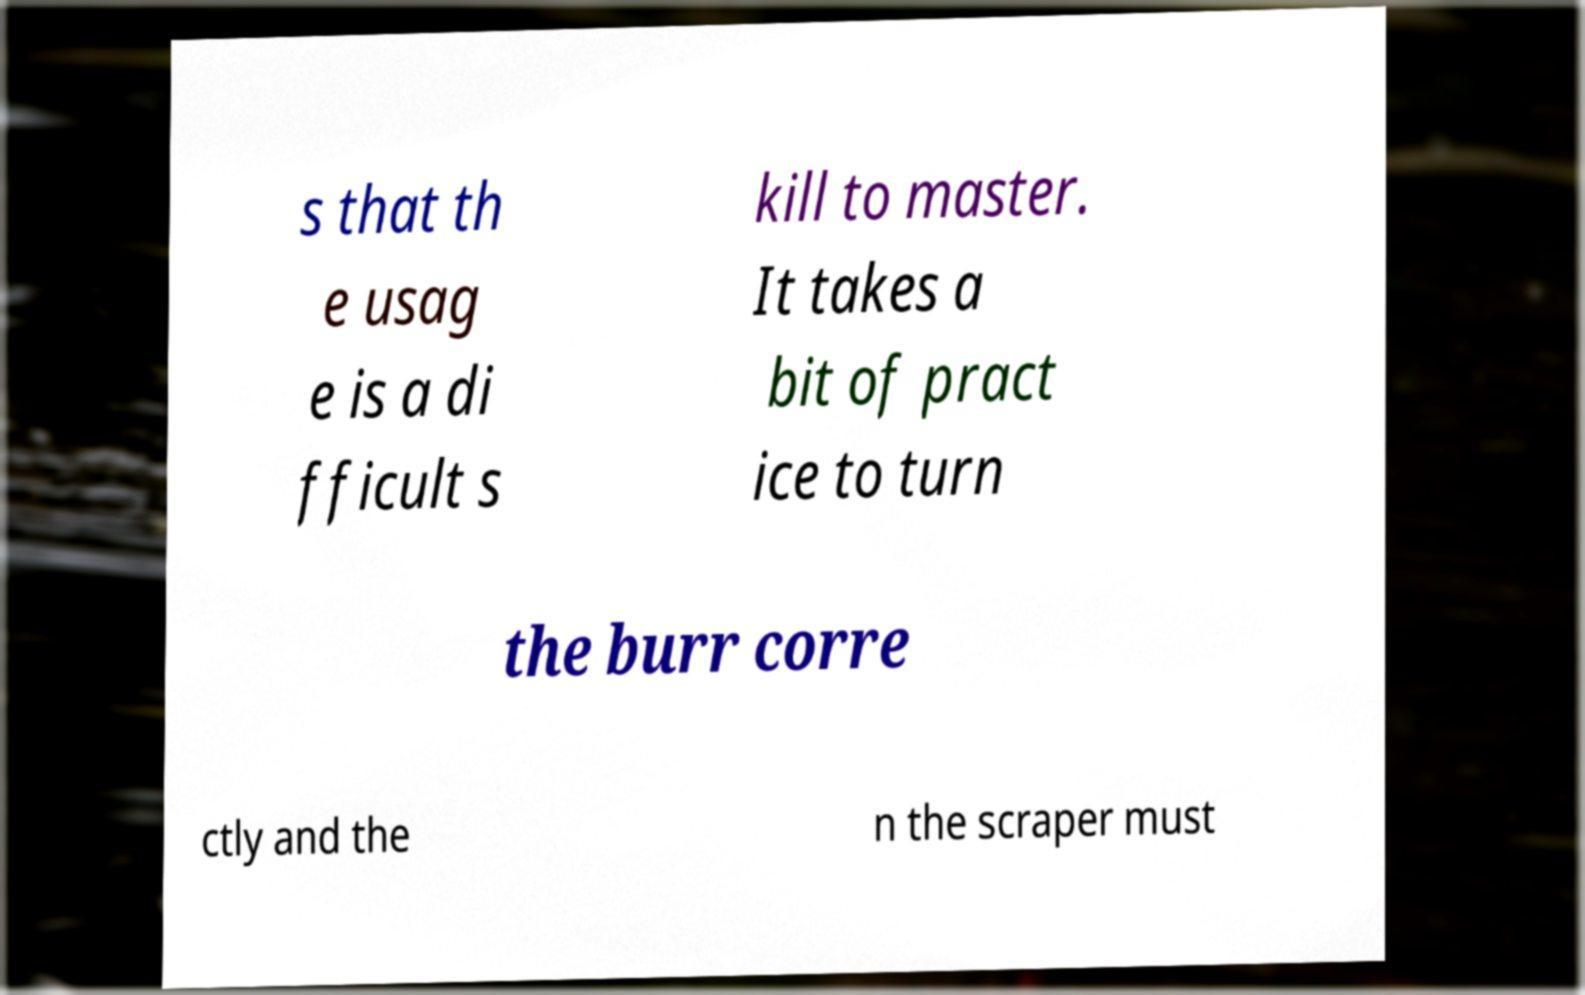Please read and relay the text visible in this image. What does it say? s that th e usag e is a di fficult s kill to master. It takes a bit of pract ice to turn the burr corre ctly and the n the scraper must 